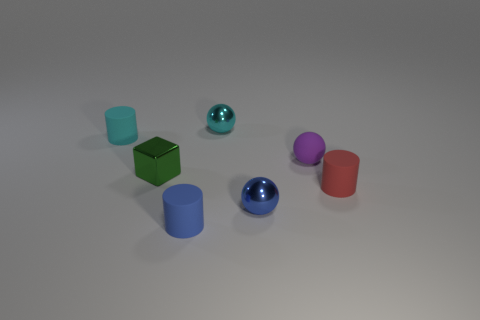Subtract 1 spheres. How many spheres are left? 2 Add 2 green metallic blocks. How many objects exist? 9 Subtract all cubes. How many objects are left? 6 Add 5 small gray shiny things. How many small gray shiny things exist? 5 Subtract 1 cyan cylinders. How many objects are left? 6 Subtract all yellow metal balls. Subtract all tiny blocks. How many objects are left? 6 Add 1 blue matte cylinders. How many blue matte cylinders are left? 2 